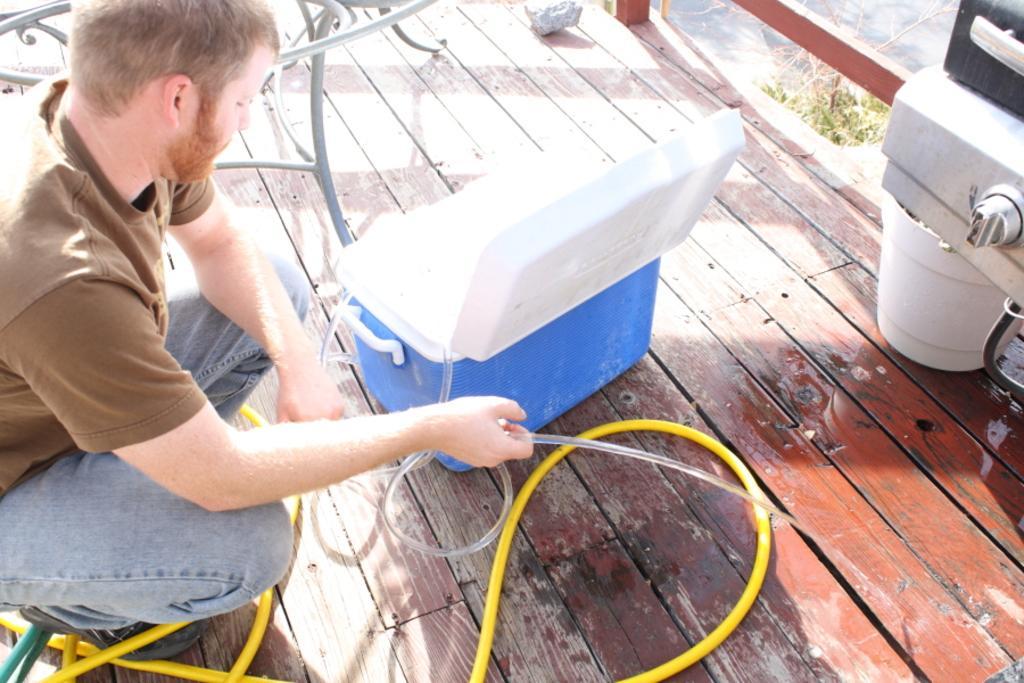Describe this image in one or two sentences. In this image there is a man sitting and holding a pipe in his hands in front of him there is a box, in the top right there are objects,behind the man there is a bench. 